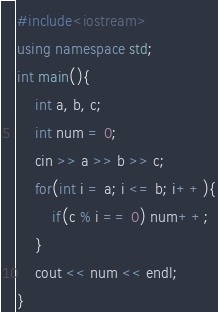<code> <loc_0><loc_0><loc_500><loc_500><_C++_>#include<iostream>
using namespace std;
int main(){
    int a, b, c;
    int num = 0;
    cin >> a >> b >> c;
    for(int i = a; i <= b; i++){
        if(c % i == 0) num++;
    }
    cout << num << endl;
}
</code> 